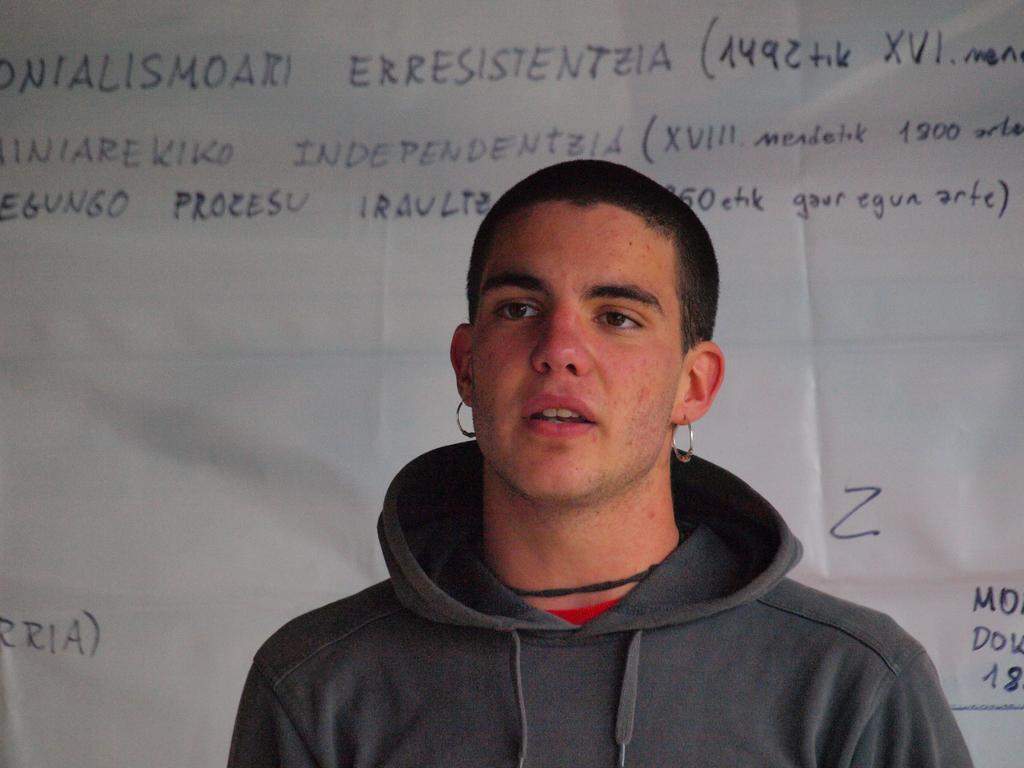What is the main subject of the image? There is a person standing in the image. What is the person wearing? The person is wearing a jacket. What can be seen in the background of the image? There is a banner in the background of the image. What is written on the banner? There is some matter written on the banner. What type of lamp is hanging from the person's neck in the image? There is no lamp present in the image; the person is wearing a jacket. Can you tell me what is inside the locket that the person is holding in the image? There is no locket present in the image; the person is wearing a jacket and standing near a banner. 